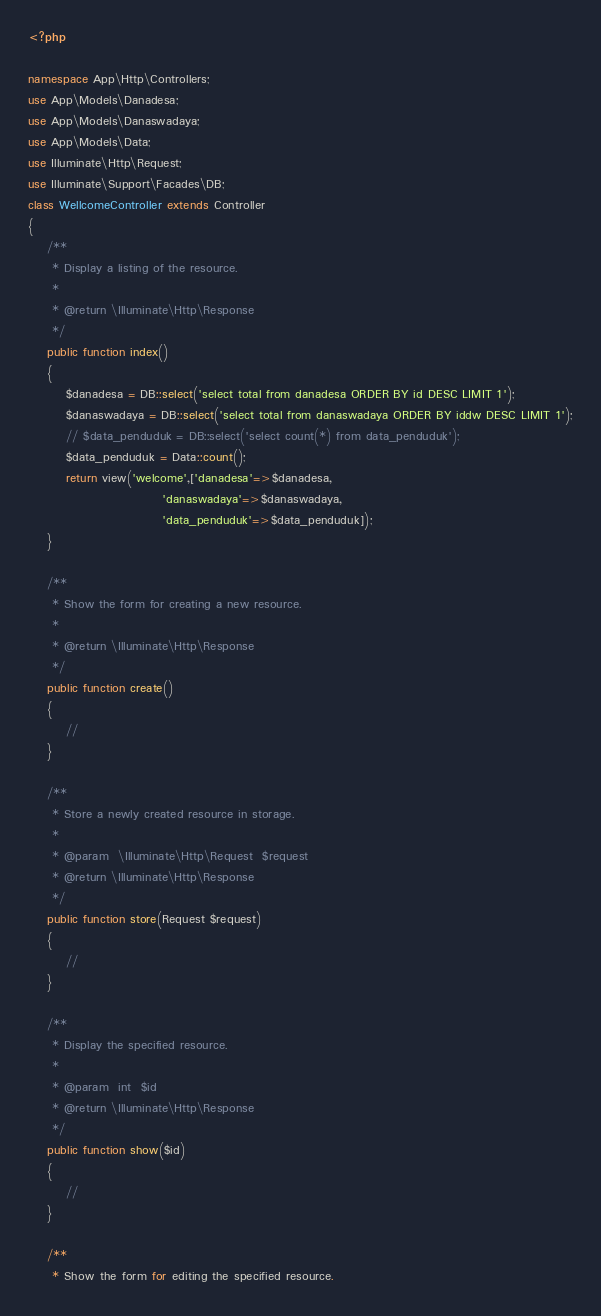<code> <loc_0><loc_0><loc_500><loc_500><_PHP_><?php

namespace App\Http\Controllers;
use App\Models\Danadesa;
use App\Models\Danaswadaya;
use App\Models\Data;
use Illuminate\Http\Request;
use Illuminate\Support\Facades\DB;
class WellcomeController extends Controller
{
    /**
     * Display a listing of the resource.
     *
     * @return \Illuminate\Http\Response
     */
    public function index()
    {
        $danadesa = DB::select('select total from danadesa ORDER BY id DESC LIMIT 1');
        $danaswadaya = DB::select('select total from danaswadaya ORDER BY iddw DESC LIMIT 1');
        // $data_penduduk = DB::select('select count(*) from data_penduduk');
        $data_penduduk = Data::count();
        return view('welcome',['danadesa'=>$danadesa, 
                            'danaswadaya'=>$danaswadaya, 
                            'data_penduduk'=>$data_penduduk]);
    }

    /**
     * Show the form for creating a new resource.
     *
     * @return \Illuminate\Http\Response
     */
    public function create()
    {
        //
    }

    /**
     * Store a newly created resource in storage.
     *
     * @param  \Illuminate\Http\Request  $request
     * @return \Illuminate\Http\Response
     */
    public function store(Request $request)
    {
        //
    }

    /**
     * Display the specified resource.
     *
     * @param  int  $id
     * @return \Illuminate\Http\Response
     */
    public function show($id)
    {
        //
    }

    /**
     * Show the form for editing the specified resource.</code> 